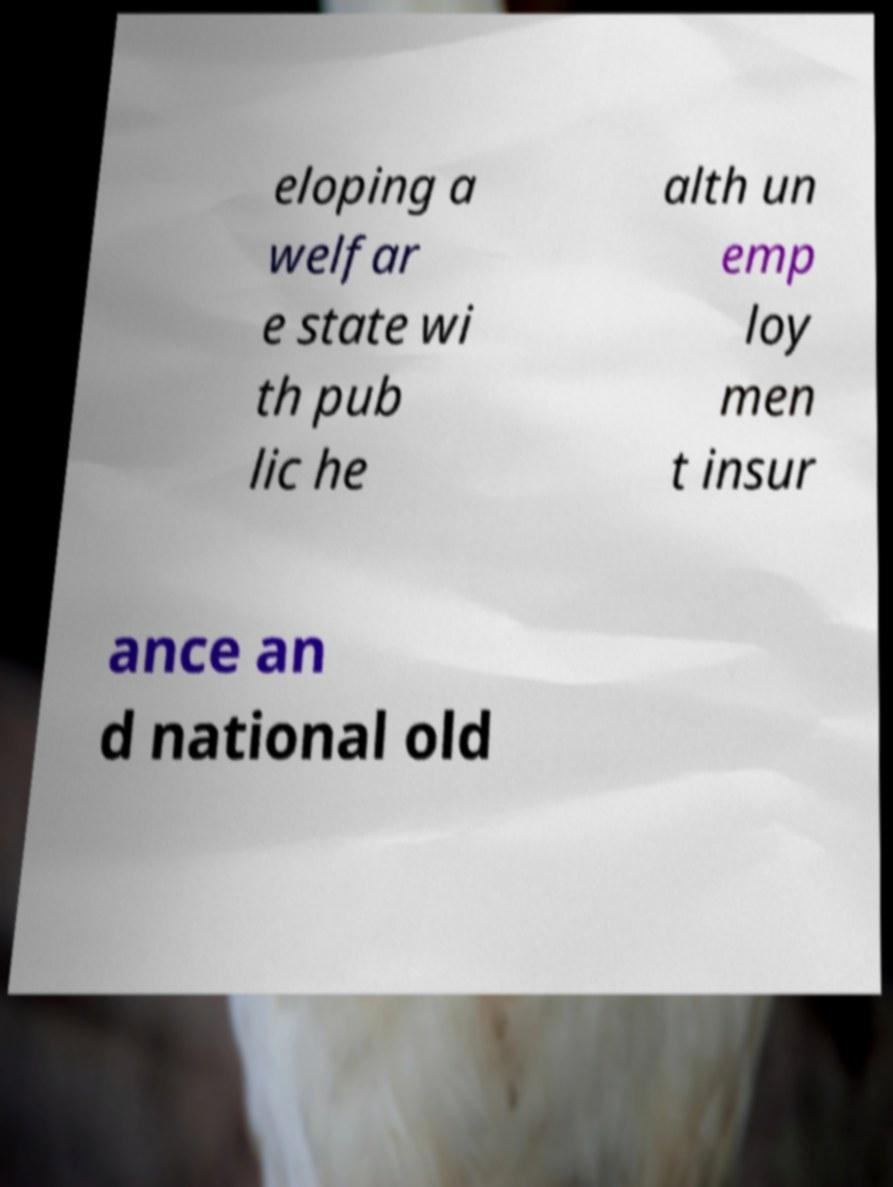Could you assist in decoding the text presented in this image and type it out clearly? eloping a welfar e state wi th pub lic he alth un emp loy men t insur ance an d national old 